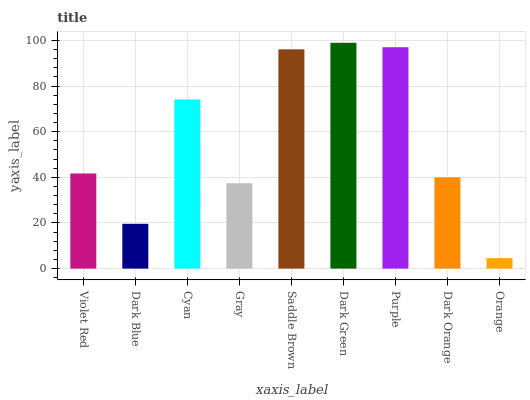Is Orange the minimum?
Answer yes or no. Yes. Is Dark Green the maximum?
Answer yes or no. Yes. Is Dark Blue the minimum?
Answer yes or no. No. Is Dark Blue the maximum?
Answer yes or no. No. Is Violet Red greater than Dark Blue?
Answer yes or no. Yes. Is Dark Blue less than Violet Red?
Answer yes or no. Yes. Is Dark Blue greater than Violet Red?
Answer yes or no. No. Is Violet Red less than Dark Blue?
Answer yes or no. No. Is Violet Red the high median?
Answer yes or no. Yes. Is Violet Red the low median?
Answer yes or no. Yes. Is Dark Orange the high median?
Answer yes or no. No. Is Dark Blue the low median?
Answer yes or no. No. 